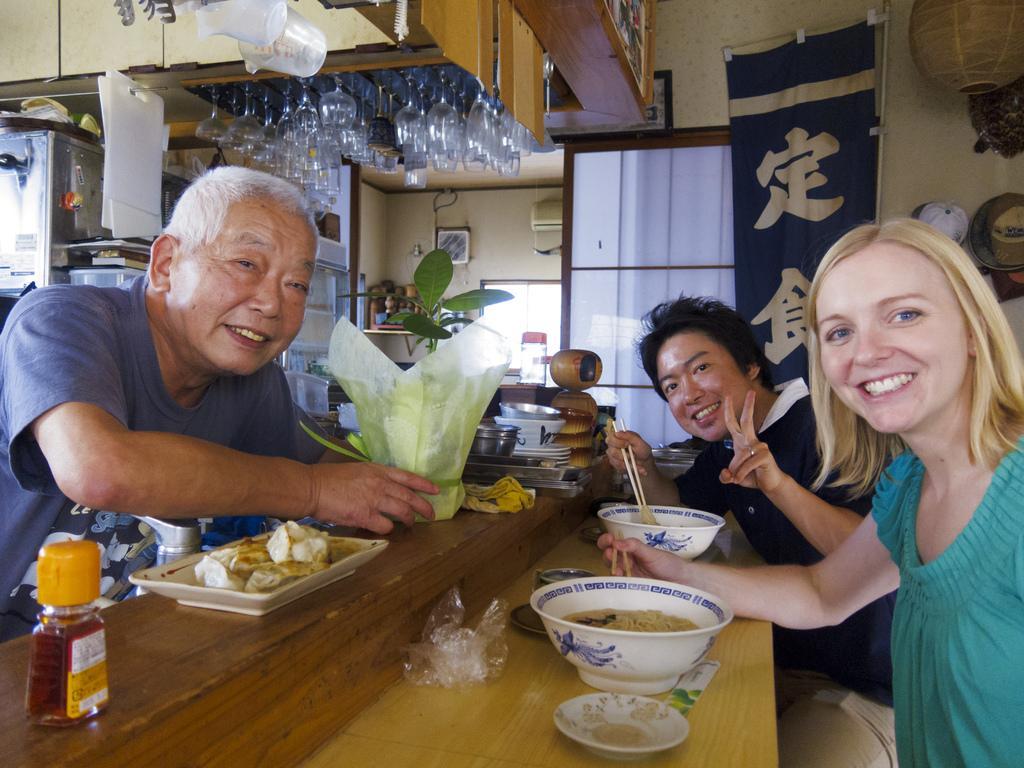In one or two sentences, can you explain what this image depicts? In this picture I can see there are three people sitting at the table and having their meal and they are smiling. There are bowls of food placed on the table and in the backdrop there are few glasses arranged and a wall. 